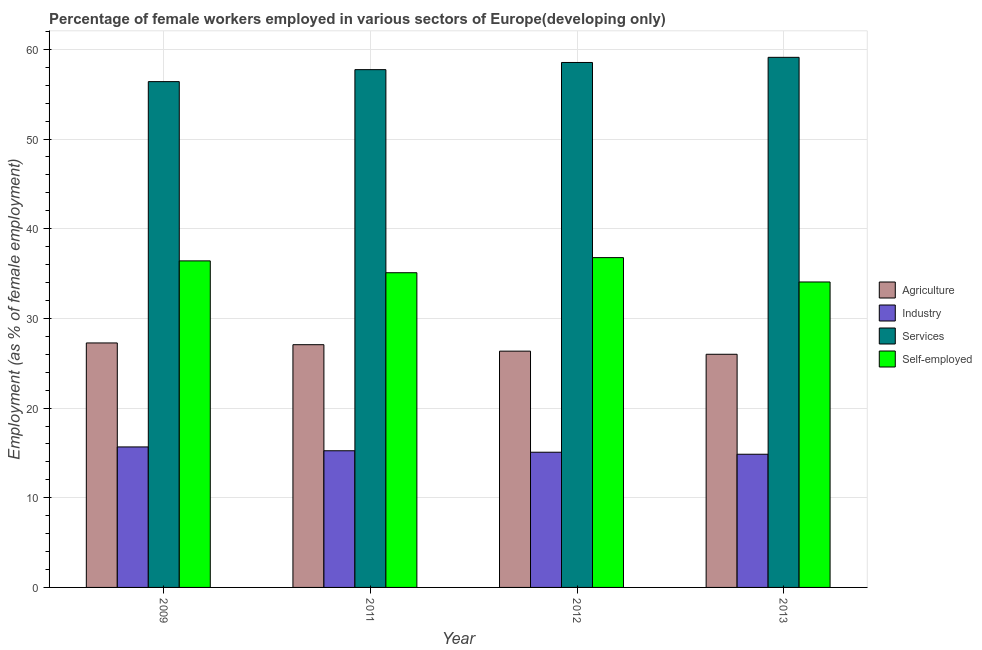How many bars are there on the 4th tick from the left?
Offer a terse response. 4. How many bars are there on the 3rd tick from the right?
Ensure brevity in your answer.  4. What is the label of the 1st group of bars from the left?
Provide a short and direct response. 2009. In how many cases, is the number of bars for a given year not equal to the number of legend labels?
Your answer should be compact. 0. What is the percentage of female workers in agriculture in 2013?
Ensure brevity in your answer.  26. Across all years, what is the maximum percentage of female workers in services?
Give a very brief answer. 59.11. Across all years, what is the minimum percentage of female workers in agriculture?
Your answer should be compact. 26. In which year was the percentage of female workers in agriculture minimum?
Make the answer very short. 2013. What is the total percentage of female workers in services in the graph?
Provide a short and direct response. 231.8. What is the difference between the percentage of female workers in services in 2011 and that in 2013?
Offer a very short reply. -1.37. What is the difference between the percentage of female workers in industry in 2009 and the percentage of female workers in services in 2012?
Give a very brief answer. 0.59. What is the average percentage of female workers in industry per year?
Make the answer very short. 15.21. What is the ratio of the percentage of female workers in services in 2012 to that in 2013?
Provide a succinct answer. 0.99. Is the difference between the percentage of female workers in agriculture in 2009 and 2013 greater than the difference between the percentage of female workers in industry in 2009 and 2013?
Make the answer very short. No. What is the difference between the highest and the second highest percentage of self employed female workers?
Your response must be concise. 0.36. What is the difference between the highest and the lowest percentage of female workers in agriculture?
Your answer should be compact. 1.26. Is the sum of the percentage of female workers in agriculture in 2009 and 2011 greater than the maximum percentage of female workers in services across all years?
Keep it short and to the point. Yes. What does the 2nd bar from the left in 2012 represents?
Provide a succinct answer. Industry. What does the 4th bar from the right in 2011 represents?
Provide a succinct answer. Agriculture. Are all the bars in the graph horizontal?
Your answer should be compact. No. How many years are there in the graph?
Provide a succinct answer. 4. Are the values on the major ticks of Y-axis written in scientific E-notation?
Your answer should be very brief. No. Does the graph contain any zero values?
Your answer should be very brief. No. Does the graph contain grids?
Your answer should be compact. Yes. Where does the legend appear in the graph?
Provide a succinct answer. Center right. How many legend labels are there?
Give a very brief answer. 4. How are the legend labels stacked?
Provide a succinct answer. Vertical. What is the title of the graph?
Your answer should be very brief. Percentage of female workers employed in various sectors of Europe(developing only). Does "Other expenses" appear as one of the legend labels in the graph?
Make the answer very short. No. What is the label or title of the Y-axis?
Your response must be concise. Employment (as % of female employment). What is the Employment (as % of female employment) in Agriculture in 2009?
Give a very brief answer. 27.26. What is the Employment (as % of female employment) of Industry in 2009?
Your response must be concise. 15.67. What is the Employment (as % of female employment) of Services in 2009?
Give a very brief answer. 56.4. What is the Employment (as % of female employment) of Self-employed in 2009?
Give a very brief answer. 36.41. What is the Employment (as % of female employment) of Agriculture in 2011?
Give a very brief answer. 27.07. What is the Employment (as % of female employment) of Industry in 2011?
Ensure brevity in your answer.  15.24. What is the Employment (as % of female employment) in Services in 2011?
Ensure brevity in your answer.  57.74. What is the Employment (as % of female employment) in Self-employed in 2011?
Ensure brevity in your answer.  35.09. What is the Employment (as % of female employment) in Agriculture in 2012?
Provide a short and direct response. 26.35. What is the Employment (as % of female employment) in Industry in 2012?
Keep it short and to the point. 15.08. What is the Employment (as % of female employment) of Services in 2012?
Ensure brevity in your answer.  58.54. What is the Employment (as % of female employment) of Self-employed in 2012?
Provide a short and direct response. 36.78. What is the Employment (as % of female employment) of Agriculture in 2013?
Your response must be concise. 26. What is the Employment (as % of female employment) of Industry in 2013?
Your response must be concise. 14.85. What is the Employment (as % of female employment) in Services in 2013?
Give a very brief answer. 59.11. What is the Employment (as % of female employment) in Self-employed in 2013?
Keep it short and to the point. 34.06. Across all years, what is the maximum Employment (as % of female employment) in Agriculture?
Provide a short and direct response. 27.26. Across all years, what is the maximum Employment (as % of female employment) of Industry?
Your answer should be very brief. 15.67. Across all years, what is the maximum Employment (as % of female employment) in Services?
Provide a succinct answer. 59.11. Across all years, what is the maximum Employment (as % of female employment) of Self-employed?
Keep it short and to the point. 36.78. Across all years, what is the minimum Employment (as % of female employment) in Agriculture?
Make the answer very short. 26. Across all years, what is the minimum Employment (as % of female employment) of Industry?
Ensure brevity in your answer.  14.85. Across all years, what is the minimum Employment (as % of female employment) of Services?
Offer a very short reply. 56.4. Across all years, what is the minimum Employment (as % of female employment) in Self-employed?
Keep it short and to the point. 34.06. What is the total Employment (as % of female employment) of Agriculture in the graph?
Provide a succinct answer. 106.68. What is the total Employment (as % of female employment) of Industry in the graph?
Provide a short and direct response. 60.84. What is the total Employment (as % of female employment) of Services in the graph?
Give a very brief answer. 231.8. What is the total Employment (as % of female employment) of Self-employed in the graph?
Make the answer very short. 142.35. What is the difference between the Employment (as % of female employment) of Agriculture in 2009 and that in 2011?
Offer a terse response. 0.19. What is the difference between the Employment (as % of female employment) of Industry in 2009 and that in 2011?
Keep it short and to the point. 0.43. What is the difference between the Employment (as % of female employment) in Services in 2009 and that in 2011?
Provide a short and direct response. -1.33. What is the difference between the Employment (as % of female employment) of Self-employed in 2009 and that in 2011?
Make the answer very short. 1.32. What is the difference between the Employment (as % of female employment) of Agriculture in 2009 and that in 2012?
Provide a succinct answer. 0.91. What is the difference between the Employment (as % of female employment) of Industry in 2009 and that in 2012?
Offer a very short reply. 0.59. What is the difference between the Employment (as % of female employment) of Services in 2009 and that in 2012?
Provide a short and direct response. -2.14. What is the difference between the Employment (as % of female employment) in Self-employed in 2009 and that in 2012?
Give a very brief answer. -0.36. What is the difference between the Employment (as % of female employment) in Agriculture in 2009 and that in 2013?
Offer a terse response. 1.26. What is the difference between the Employment (as % of female employment) of Industry in 2009 and that in 2013?
Ensure brevity in your answer.  0.82. What is the difference between the Employment (as % of female employment) of Services in 2009 and that in 2013?
Your answer should be very brief. -2.71. What is the difference between the Employment (as % of female employment) of Self-employed in 2009 and that in 2013?
Your answer should be very brief. 2.35. What is the difference between the Employment (as % of female employment) in Agriculture in 2011 and that in 2012?
Give a very brief answer. 0.72. What is the difference between the Employment (as % of female employment) in Industry in 2011 and that in 2012?
Ensure brevity in your answer.  0.16. What is the difference between the Employment (as % of female employment) in Services in 2011 and that in 2012?
Give a very brief answer. -0.8. What is the difference between the Employment (as % of female employment) in Self-employed in 2011 and that in 2012?
Give a very brief answer. -1.69. What is the difference between the Employment (as % of female employment) of Agriculture in 2011 and that in 2013?
Offer a very short reply. 1.07. What is the difference between the Employment (as % of female employment) in Industry in 2011 and that in 2013?
Make the answer very short. 0.39. What is the difference between the Employment (as % of female employment) in Services in 2011 and that in 2013?
Ensure brevity in your answer.  -1.37. What is the difference between the Employment (as % of female employment) in Self-employed in 2011 and that in 2013?
Give a very brief answer. 1.03. What is the difference between the Employment (as % of female employment) in Agriculture in 2012 and that in 2013?
Your response must be concise. 0.35. What is the difference between the Employment (as % of female employment) of Industry in 2012 and that in 2013?
Provide a succinct answer. 0.23. What is the difference between the Employment (as % of female employment) of Services in 2012 and that in 2013?
Your answer should be compact. -0.57. What is the difference between the Employment (as % of female employment) in Self-employed in 2012 and that in 2013?
Provide a short and direct response. 2.72. What is the difference between the Employment (as % of female employment) in Agriculture in 2009 and the Employment (as % of female employment) in Industry in 2011?
Keep it short and to the point. 12.02. What is the difference between the Employment (as % of female employment) of Agriculture in 2009 and the Employment (as % of female employment) of Services in 2011?
Provide a short and direct response. -30.48. What is the difference between the Employment (as % of female employment) of Agriculture in 2009 and the Employment (as % of female employment) of Self-employed in 2011?
Your response must be concise. -7.83. What is the difference between the Employment (as % of female employment) of Industry in 2009 and the Employment (as % of female employment) of Services in 2011?
Ensure brevity in your answer.  -42.07. What is the difference between the Employment (as % of female employment) in Industry in 2009 and the Employment (as % of female employment) in Self-employed in 2011?
Your answer should be compact. -19.42. What is the difference between the Employment (as % of female employment) of Services in 2009 and the Employment (as % of female employment) of Self-employed in 2011?
Your answer should be compact. 21.31. What is the difference between the Employment (as % of female employment) of Agriculture in 2009 and the Employment (as % of female employment) of Industry in 2012?
Give a very brief answer. 12.19. What is the difference between the Employment (as % of female employment) in Agriculture in 2009 and the Employment (as % of female employment) in Services in 2012?
Your answer should be compact. -31.28. What is the difference between the Employment (as % of female employment) in Agriculture in 2009 and the Employment (as % of female employment) in Self-employed in 2012?
Your response must be concise. -9.52. What is the difference between the Employment (as % of female employment) of Industry in 2009 and the Employment (as % of female employment) of Services in 2012?
Ensure brevity in your answer.  -42.87. What is the difference between the Employment (as % of female employment) of Industry in 2009 and the Employment (as % of female employment) of Self-employed in 2012?
Your response must be concise. -21.11. What is the difference between the Employment (as % of female employment) in Services in 2009 and the Employment (as % of female employment) in Self-employed in 2012?
Your answer should be compact. 19.63. What is the difference between the Employment (as % of female employment) of Agriculture in 2009 and the Employment (as % of female employment) of Industry in 2013?
Your response must be concise. 12.41. What is the difference between the Employment (as % of female employment) in Agriculture in 2009 and the Employment (as % of female employment) in Services in 2013?
Give a very brief answer. -31.85. What is the difference between the Employment (as % of female employment) of Agriculture in 2009 and the Employment (as % of female employment) of Self-employed in 2013?
Give a very brief answer. -6.8. What is the difference between the Employment (as % of female employment) in Industry in 2009 and the Employment (as % of female employment) in Services in 2013?
Your answer should be compact. -43.45. What is the difference between the Employment (as % of female employment) of Industry in 2009 and the Employment (as % of female employment) of Self-employed in 2013?
Offer a very short reply. -18.39. What is the difference between the Employment (as % of female employment) in Services in 2009 and the Employment (as % of female employment) in Self-employed in 2013?
Your response must be concise. 22.34. What is the difference between the Employment (as % of female employment) of Agriculture in 2011 and the Employment (as % of female employment) of Industry in 2012?
Provide a succinct answer. 11.99. What is the difference between the Employment (as % of female employment) in Agriculture in 2011 and the Employment (as % of female employment) in Services in 2012?
Make the answer very short. -31.47. What is the difference between the Employment (as % of female employment) of Agriculture in 2011 and the Employment (as % of female employment) of Self-employed in 2012?
Make the answer very short. -9.71. What is the difference between the Employment (as % of female employment) in Industry in 2011 and the Employment (as % of female employment) in Services in 2012?
Your response must be concise. -43.3. What is the difference between the Employment (as % of female employment) in Industry in 2011 and the Employment (as % of female employment) in Self-employed in 2012?
Offer a very short reply. -21.54. What is the difference between the Employment (as % of female employment) in Services in 2011 and the Employment (as % of female employment) in Self-employed in 2012?
Make the answer very short. 20.96. What is the difference between the Employment (as % of female employment) of Agriculture in 2011 and the Employment (as % of female employment) of Industry in 2013?
Keep it short and to the point. 12.22. What is the difference between the Employment (as % of female employment) of Agriculture in 2011 and the Employment (as % of female employment) of Services in 2013?
Provide a short and direct response. -32.05. What is the difference between the Employment (as % of female employment) in Agriculture in 2011 and the Employment (as % of female employment) in Self-employed in 2013?
Your answer should be compact. -6.99. What is the difference between the Employment (as % of female employment) in Industry in 2011 and the Employment (as % of female employment) in Services in 2013?
Make the answer very short. -43.87. What is the difference between the Employment (as % of female employment) in Industry in 2011 and the Employment (as % of female employment) in Self-employed in 2013?
Provide a short and direct response. -18.82. What is the difference between the Employment (as % of female employment) in Services in 2011 and the Employment (as % of female employment) in Self-employed in 2013?
Give a very brief answer. 23.68. What is the difference between the Employment (as % of female employment) in Agriculture in 2012 and the Employment (as % of female employment) in Industry in 2013?
Provide a succinct answer. 11.5. What is the difference between the Employment (as % of female employment) in Agriculture in 2012 and the Employment (as % of female employment) in Services in 2013?
Your response must be concise. -32.77. What is the difference between the Employment (as % of female employment) in Agriculture in 2012 and the Employment (as % of female employment) in Self-employed in 2013?
Your answer should be compact. -7.71. What is the difference between the Employment (as % of female employment) in Industry in 2012 and the Employment (as % of female employment) in Services in 2013?
Provide a short and direct response. -44.04. What is the difference between the Employment (as % of female employment) in Industry in 2012 and the Employment (as % of female employment) in Self-employed in 2013?
Offer a very short reply. -18.99. What is the difference between the Employment (as % of female employment) of Services in 2012 and the Employment (as % of female employment) of Self-employed in 2013?
Offer a terse response. 24.48. What is the average Employment (as % of female employment) in Agriculture per year?
Keep it short and to the point. 26.67. What is the average Employment (as % of female employment) of Industry per year?
Keep it short and to the point. 15.21. What is the average Employment (as % of female employment) of Services per year?
Provide a short and direct response. 57.95. What is the average Employment (as % of female employment) of Self-employed per year?
Offer a terse response. 35.59. In the year 2009, what is the difference between the Employment (as % of female employment) of Agriculture and Employment (as % of female employment) of Industry?
Offer a very short reply. 11.59. In the year 2009, what is the difference between the Employment (as % of female employment) in Agriculture and Employment (as % of female employment) in Services?
Your answer should be compact. -29.14. In the year 2009, what is the difference between the Employment (as % of female employment) in Agriculture and Employment (as % of female employment) in Self-employed?
Make the answer very short. -9.15. In the year 2009, what is the difference between the Employment (as % of female employment) in Industry and Employment (as % of female employment) in Services?
Your response must be concise. -40.74. In the year 2009, what is the difference between the Employment (as % of female employment) in Industry and Employment (as % of female employment) in Self-employed?
Ensure brevity in your answer.  -20.75. In the year 2009, what is the difference between the Employment (as % of female employment) of Services and Employment (as % of female employment) of Self-employed?
Give a very brief answer. 19.99. In the year 2011, what is the difference between the Employment (as % of female employment) in Agriculture and Employment (as % of female employment) in Industry?
Your answer should be very brief. 11.83. In the year 2011, what is the difference between the Employment (as % of female employment) of Agriculture and Employment (as % of female employment) of Services?
Ensure brevity in your answer.  -30.67. In the year 2011, what is the difference between the Employment (as % of female employment) in Agriculture and Employment (as % of female employment) in Self-employed?
Your answer should be very brief. -8.02. In the year 2011, what is the difference between the Employment (as % of female employment) in Industry and Employment (as % of female employment) in Services?
Offer a terse response. -42.5. In the year 2011, what is the difference between the Employment (as % of female employment) in Industry and Employment (as % of female employment) in Self-employed?
Make the answer very short. -19.85. In the year 2011, what is the difference between the Employment (as % of female employment) in Services and Employment (as % of female employment) in Self-employed?
Ensure brevity in your answer.  22.65. In the year 2012, what is the difference between the Employment (as % of female employment) in Agriculture and Employment (as % of female employment) in Industry?
Your answer should be very brief. 11.27. In the year 2012, what is the difference between the Employment (as % of female employment) in Agriculture and Employment (as % of female employment) in Services?
Provide a succinct answer. -32.19. In the year 2012, what is the difference between the Employment (as % of female employment) of Agriculture and Employment (as % of female employment) of Self-employed?
Your answer should be very brief. -10.43. In the year 2012, what is the difference between the Employment (as % of female employment) in Industry and Employment (as % of female employment) in Services?
Offer a very short reply. -43.46. In the year 2012, what is the difference between the Employment (as % of female employment) in Industry and Employment (as % of female employment) in Self-employed?
Offer a terse response. -21.7. In the year 2012, what is the difference between the Employment (as % of female employment) in Services and Employment (as % of female employment) in Self-employed?
Your response must be concise. 21.76. In the year 2013, what is the difference between the Employment (as % of female employment) of Agriculture and Employment (as % of female employment) of Industry?
Your answer should be very brief. 11.15. In the year 2013, what is the difference between the Employment (as % of female employment) of Agriculture and Employment (as % of female employment) of Services?
Keep it short and to the point. -33.11. In the year 2013, what is the difference between the Employment (as % of female employment) of Agriculture and Employment (as % of female employment) of Self-employed?
Give a very brief answer. -8.06. In the year 2013, what is the difference between the Employment (as % of female employment) in Industry and Employment (as % of female employment) in Services?
Your response must be concise. -44.26. In the year 2013, what is the difference between the Employment (as % of female employment) of Industry and Employment (as % of female employment) of Self-employed?
Your answer should be compact. -19.21. In the year 2013, what is the difference between the Employment (as % of female employment) in Services and Employment (as % of female employment) in Self-employed?
Make the answer very short. 25.05. What is the ratio of the Employment (as % of female employment) in Agriculture in 2009 to that in 2011?
Your answer should be very brief. 1.01. What is the ratio of the Employment (as % of female employment) of Industry in 2009 to that in 2011?
Offer a very short reply. 1.03. What is the ratio of the Employment (as % of female employment) in Services in 2009 to that in 2011?
Give a very brief answer. 0.98. What is the ratio of the Employment (as % of female employment) in Self-employed in 2009 to that in 2011?
Your answer should be very brief. 1.04. What is the ratio of the Employment (as % of female employment) in Agriculture in 2009 to that in 2012?
Provide a succinct answer. 1.03. What is the ratio of the Employment (as % of female employment) of Industry in 2009 to that in 2012?
Your response must be concise. 1.04. What is the ratio of the Employment (as % of female employment) in Services in 2009 to that in 2012?
Your response must be concise. 0.96. What is the ratio of the Employment (as % of female employment) in Agriculture in 2009 to that in 2013?
Offer a very short reply. 1.05. What is the ratio of the Employment (as % of female employment) of Industry in 2009 to that in 2013?
Your answer should be compact. 1.05. What is the ratio of the Employment (as % of female employment) in Services in 2009 to that in 2013?
Give a very brief answer. 0.95. What is the ratio of the Employment (as % of female employment) in Self-employed in 2009 to that in 2013?
Offer a terse response. 1.07. What is the ratio of the Employment (as % of female employment) of Agriculture in 2011 to that in 2012?
Give a very brief answer. 1.03. What is the ratio of the Employment (as % of female employment) in Industry in 2011 to that in 2012?
Give a very brief answer. 1.01. What is the ratio of the Employment (as % of female employment) of Services in 2011 to that in 2012?
Provide a succinct answer. 0.99. What is the ratio of the Employment (as % of female employment) of Self-employed in 2011 to that in 2012?
Keep it short and to the point. 0.95. What is the ratio of the Employment (as % of female employment) of Agriculture in 2011 to that in 2013?
Provide a succinct answer. 1.04. What is the ratio of the Employment (as % of female employment) of Industry in 2011 to that in 2013?
Give a very brief answer. 1.03. What is the ratio of the Employment (as % of female employment) of Services in 2011 to that in 2013?
Provide a short and direct response. 0.98. What is the ratio of the Employment (as % of female employment) of Self-employed in 2011 to that in 2013?
Offer a terse response. 1.03. What is the ratio of the Employment (as % of female employment) of Agriculture in 2012 to that in 2013?
Provide a short and direct response. 1.01. What is the ratio of the Employment (as % of female employment) in Industry in 2012 to that in 2013?
Make the answer very short. 1.02. What is the ratio of the Employment (as % of female employment) of Services in 2012 to that in 2013?
Give a very brief answer. 0.99. What is the ratio of the Employment (as % of female employment) in Self-employed in 2012 to that in 2013?
Offer a very short reply. 1.08. What is the difference between the highest and the second highest Employment (as % of female employment) of Agriculture?
Keep it short and to the point. 0.19. What is the difference between the highest and the second highest Employment (as % of female employment) in Industry?
Offer a very short reply. 0.43. What is the difference between the highest and the second highest Employment (as % of female employment) in Services?
Your answer should be compact. 0.57. What is the difference between the highest and the second highest Employment (as % of female employment) in Self-employed?
Make the answer very short. 0.36. What is the difference between the highest and the lowest Employment (as % of female employment) of Agriculture?
Your response must be concise. 1.26. What is the difference between the highest and the lowest Employment (as % of female employment) in Industry?
Keep it short and to the point. 0.82. What is the difference between the highest and the lowest Employment (as % of female employment) of Services?
Ensure brevity in your answer.  2.71. What is the difference between the highest and the lowest Employment (as % of female employment) in Self-employed?
Ensure brevity in your answer.  2.72. 